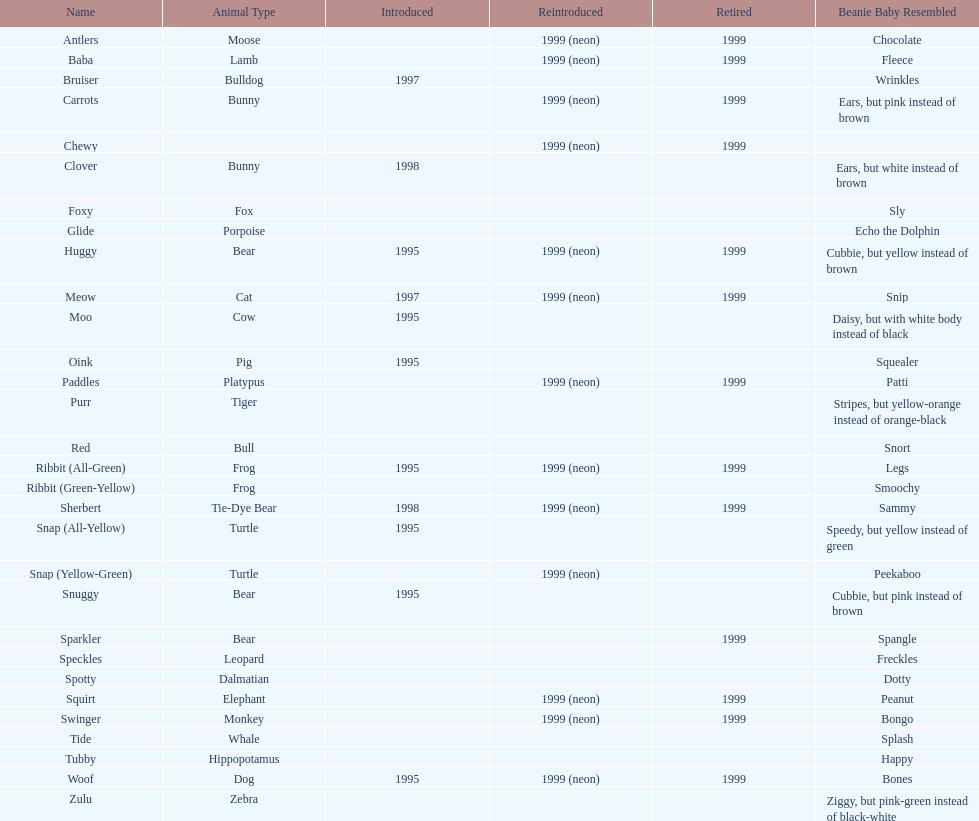What are the total number of pillow pals on this chart? 30. 